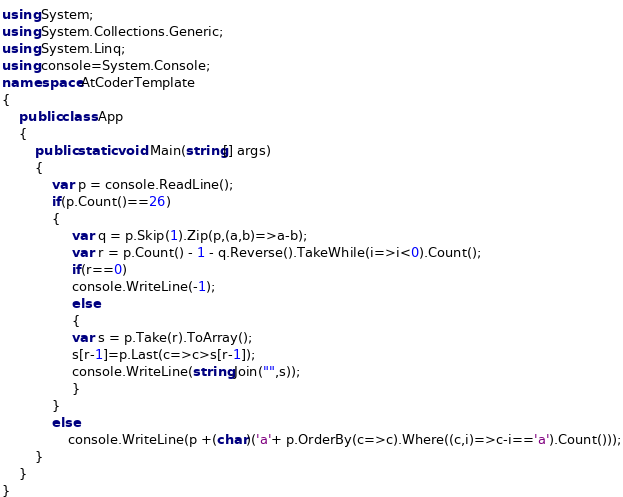Convert code to text. <code><loc_0><loc_0><loc_500><loc_500><_C#_>using System;
using System.Collections.Generic;
using System.Linq;
using console=System.Console;
namespace AtCoderTemplate
{
    public class App
    {
        public static void Main(string[] args)
        {
            var p = console.ReadLine();
            if(p.Count()==26)
            {
                 var q = p.Skip(1).Zip(p,(a,b)=>a-b);
                 var r = p.Count() - 1 - q.Reverse().TakeWhile(i=>i<0).Count();
                 if(r==0)
                 console.WriteLine(-1);
                 else
                 {
                 var s = p.Take(r).ToArray();
                 s[r-1]=p.Last(c=>c>s[r-1]);
                 console.WriteLine(string.Join("",s));
                 }
            }
            else
                console.WriteLine(p +(char)('a'+ p.OrderBy(c=>c).Where((c,i)=>c-i=='a').Count()));
        }
    }
}
</code> 